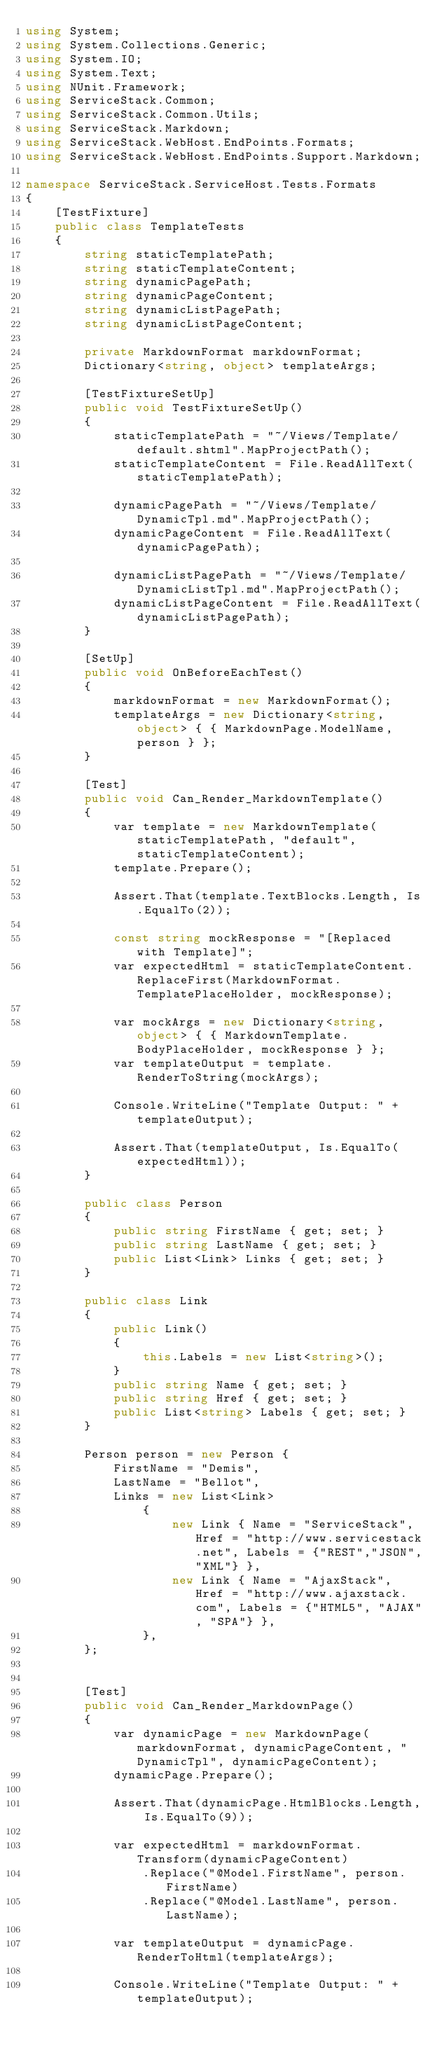Convert code to text. <code><loc_0><loc_0><loc_500><loc_500><_C#_>using System;
using System.Collections.Generic;
using System.IO;
using System.Text;
using NUnit.Framework;
using ServiceStack.Common;
using ServiceStack.Common.Utils;
using ServiceStack.Markdown;
using ServiceStack.WebHost.EndPoints.Formats;
using ServiceStack.WebHost.EndPoints.Support.Markdown;

namespace ServiceStack.ServiceHost.Tests.Formats
{
	[TestFixture]
	public class TemplateTests
	{
		string staticTemplatePath;
		string staticTemplateContent;
		string dynamicPagePath;
		string dynamicPageContent;
		string dynamicListPagePath;
		string dynamicListPageContent;

		private MarkdownFormat markdownFormat;
		Dictionary<string, object> templateArgs;

		[TestFixtureSetUp]
		public void TestFixtureSetUp()
		{
			staticTemplatePath = "~/Views/Template/default.shtml".MapProjectPath();
			staticTemplateContent = File.ReadAllText(staticTemplatePath);

			dynamicPagePath = "~/Views/Template/DynamicTpl.md".MapProjectPath();
			dynamicPageContent = File.ReadAllText(dynamicPagePath);

			dynamicListPagePath = "~/Views/Template/DynamicListTpl.md".MapProjectPath();
			dynamicListPageContent = File.ReadAllText(dynamicListPagePath);
		}

		[SetUp]
		public void OnBeforeEachTest()
		{
			markdownFormat = new MarkdownFormat();
			templateArgs = new Dictionary<string, object> { { MarkdownPage.ModelName, person } };
		}

		[Test]
		public void Can_Render_MarkdownTemplate()
		{
			var template = new MarkdownTemplate(staticTemplatePath, "default", staticTemplateContent);
			template.Prepare();

			Assert.That(template.TextBlocks.Length, Is.EqualTo(2));

			const string mockResponse = "[Replaced with Template]";
			var expectedHtml = staticTemplateContent.ReplaceFirst(MarkdownFormat.TemplatePlaceHolder, mockResponse);

			var mockArgs = new Dictionary<string, object> { { MarkdownTemplate.BodyPlaceHolder, mockResponse } };
			var templateOutput = template.RenderToString(mockArgs);

			Console.WriteLine("Template Output: " + templateOutput);

			Assert.That(templateOutput, Is.EqualTo(expectedHtml));
		}

		public class Person
		{
			public string FirstName { get; set; }
			public string LastName { get; set; }
			public List<Link> Links { get; set; }
		}

		public class Link
		{
			public Link()
			{
				this.Labels = new List<string>();
			}
			public string Name { get; set; }
			public string Href { get; set; }
			public List<string> Labels { get; set; }
		}

		Person person = new Person {
			FirstName = "Demis",
			LastName = "Bellot",
			Links = new List<Link>
				{
					new Link { Name = "ServiceStack", Href = "http://www.servicestack.net", Labels = {"REST","JSON","XML"} },
					new Link { Name = "AjaxStack", Href = "http://www.ajaxstack.com", Labels = {"HTML5", "AJAX", "SPA"} },
				},
		};


		[Test]
		public void Can_Render_MarkdownPage()
		{
			var dynamicPage = new MarkdownPage(markdownFormat, dynamicPageContent, "DynamicTpl", dynamicPageContent);
			dynamicPage.Prepare();

			Assert.That(dynamicPage.HtmlBlocks.Length, Is.EqualTo(9));

			var expectedHtml = markdownFormat.Transform(dynamicPageContent)
				.Replace("@Model.FirstName", person.FirstName)
				.Replace("@Model.LastName", person.LastName);

			var templateOutput = dynamicPage.RenderToHtml(templateArgs);

			Console.WriteLine("Template Output: " + templateOutput);
</code> 